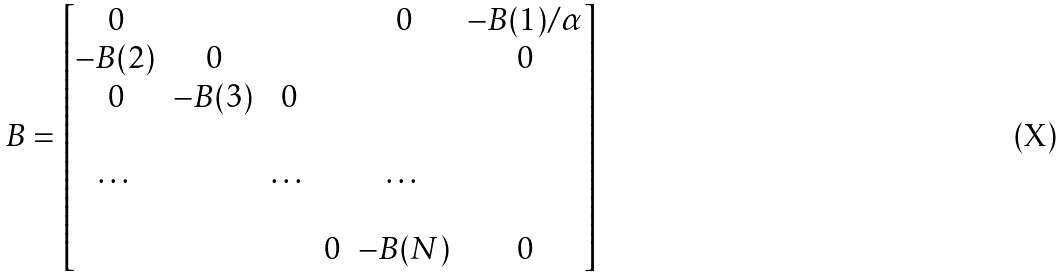Convert formula to latex. <formula><loc_0><loc_0><loc_500><loc_500>B = \begin{bmatrix} 0 & & & & 0 & - B ( 1 ) / \alpha \\ - B ( 2 ) & 0 & & & & 0 \\ 0 & - B ( 3 ) & 0 & & & \\ & & & & & \\ \dots & & \dots & & \dots & \\ & & & & & \\ & & & 0 & - B ( N ) & 0 \end{bmatrix}</formula> 